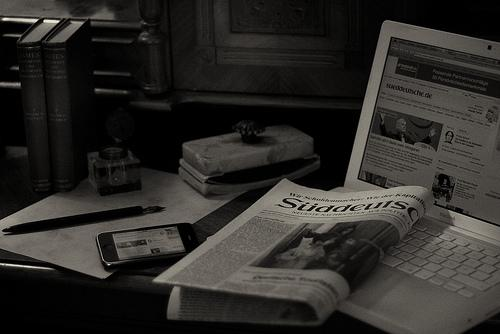What kind of device is placed on the table with a newspaper on top of it? A white laptop. Count the total number of books in the image. There are two books in the image. What type of image is displayed on the cellphone? A landscape screen is displayed on the smart phone. Analyze the sentiment of the image. The sentiment of the image is neutral, as it depicts a typical workplace scenario without any emotional elements. What color is the laptop in the image?  The laptop is white. Please provide a brief overview of the items on the desk. There is a white laptop with a newspaper on it, a cellphone, two books, a pen, a paper, a bottle of ink, and a marble paperweight on the desk. Is there any interaction between the pen and other objects in the image? If so, describe it. Yes, the pen is laying on a piece of paper, indicating that it might have been used for writing or drawing on it. Briefly describe the scene in terms of black and white color usage. The photo is in black and white, highlighting the objects on the desk such as the laptop, cellphone, pen, ink bottle, and paper. Can you describe the main content of the folded newspaper on top of the laptop in a few words? There is a picture on the front page of the folded newspaper. Can you identify and describe the pen in the image? There is a black calligraphy pen on top of a desk, laying on a piece of paper. Is the photo on the wall in color or black and white? Black and white What is the position of the pen on the paper? Laying What is displayed on the laptop screen? A webpage What is sitting on the keyboard of the white laptop? Folded newspaper Is the laptop in the image open or closed? Open Select the best description for the books' position on the desk from the options below: B. Two books stacked on top of each other. Identify which object can be described as "landscape screen on a smart phone". Cellphone on the desk What is the color of the laptop's keyboard? White What kind of ink pen is on the paper? A black calligraphy pen What is the object with coordinates X:197 Y:196? Newspaper on the laptop Imagine a scene with the white laptop, pen and inkwell, and folded newspaper on a wooden desk. What is an activity that someone might do at this desk? Writing a letter, reading the newspaper, or using the laptop. Is the laptop's screen turned on or off? On What kind of paper is present in the image? A blank piece of white paper Provide a description of the setting of the image. A wooden desk with a white laptop, folded newspaper, cellphone, pen and inkwell, two books, and a black and white picture on the wall. Which object is paired with the ink pen on the paper? Ink bottle What is the content of the folded newspaper? Picture on the front page Identify the object that can be described as "a square glass ink well". Ink bottle on the paper 